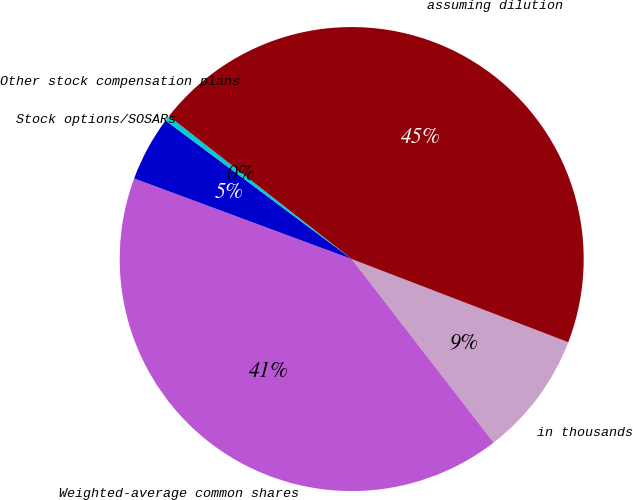<chart> <loc_0><loc_0><loc_500><loc_500><pie_chart><fcel>in thousands<fcel>Weighted-average common shares<fcel>Stock options/SOSARs<fcel>Other stock compensation plans<fcel>assuming dilution<nl><fcel>8.69%<fcel>41.12%<fcel>4.54%<fcel>0.38%<fcel>45.27%<nl></chart> 